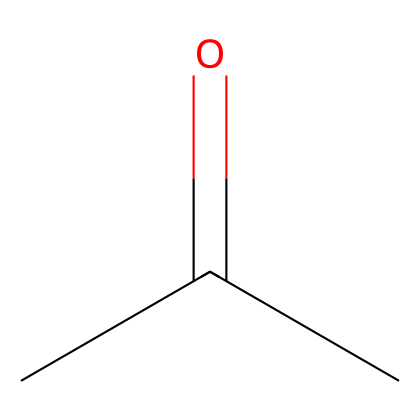What is the molecular formula of this compound? The structure provided can be deduced into its molecular formula. From the SMILES representation, we can see there are three carbon atoms (C) and six hydrogen atoms (H) plus one oxygen atom (O). Thus, the molecular formula can be represented as C3H6O.
Answer: C3H6O How many carbon atoms are in this molecule? By analyzing the structure derived from the SMILES notation, we observe there are three 'C' (carbon) notations, indicating there are three carbon atoms present.
Answer: 3 What type of functional group is present in acetone? Acetone has a carbonyl group (C=O) present in its structure, which is characteristic of ketones. This can be identified in the structure where a carbon atom is double-bonded to an oxygen atom, a defining feature of keto functional groups.
Answer: carbonyl What is the relationship between acetone and its use as a solvent? Acetone has a polar nature and can dissolve a variety of substances due to its ability to interact with both polar and non-polar molecules. The presence of the carbonyl group enhances its solvent properties, making it effective in nail polish remover.
Answer: polarity What is the degree of unsaturation in this molecule? The degree of unsaturation can be calculated based on the number of pi bonds or rings present. In acetone’s structure, there is one double bond (C=O) without any rings, leading to a degree of unsaturation of one.
Answer: 1 How many total atoms are present in acetone? By adding up the atoms from the molecular formula, acetone has 3 carbon atoms, 6 hydrogen atoms, and 1 oxygen atom, totaling 10 atoms overall.
Answer: 10 